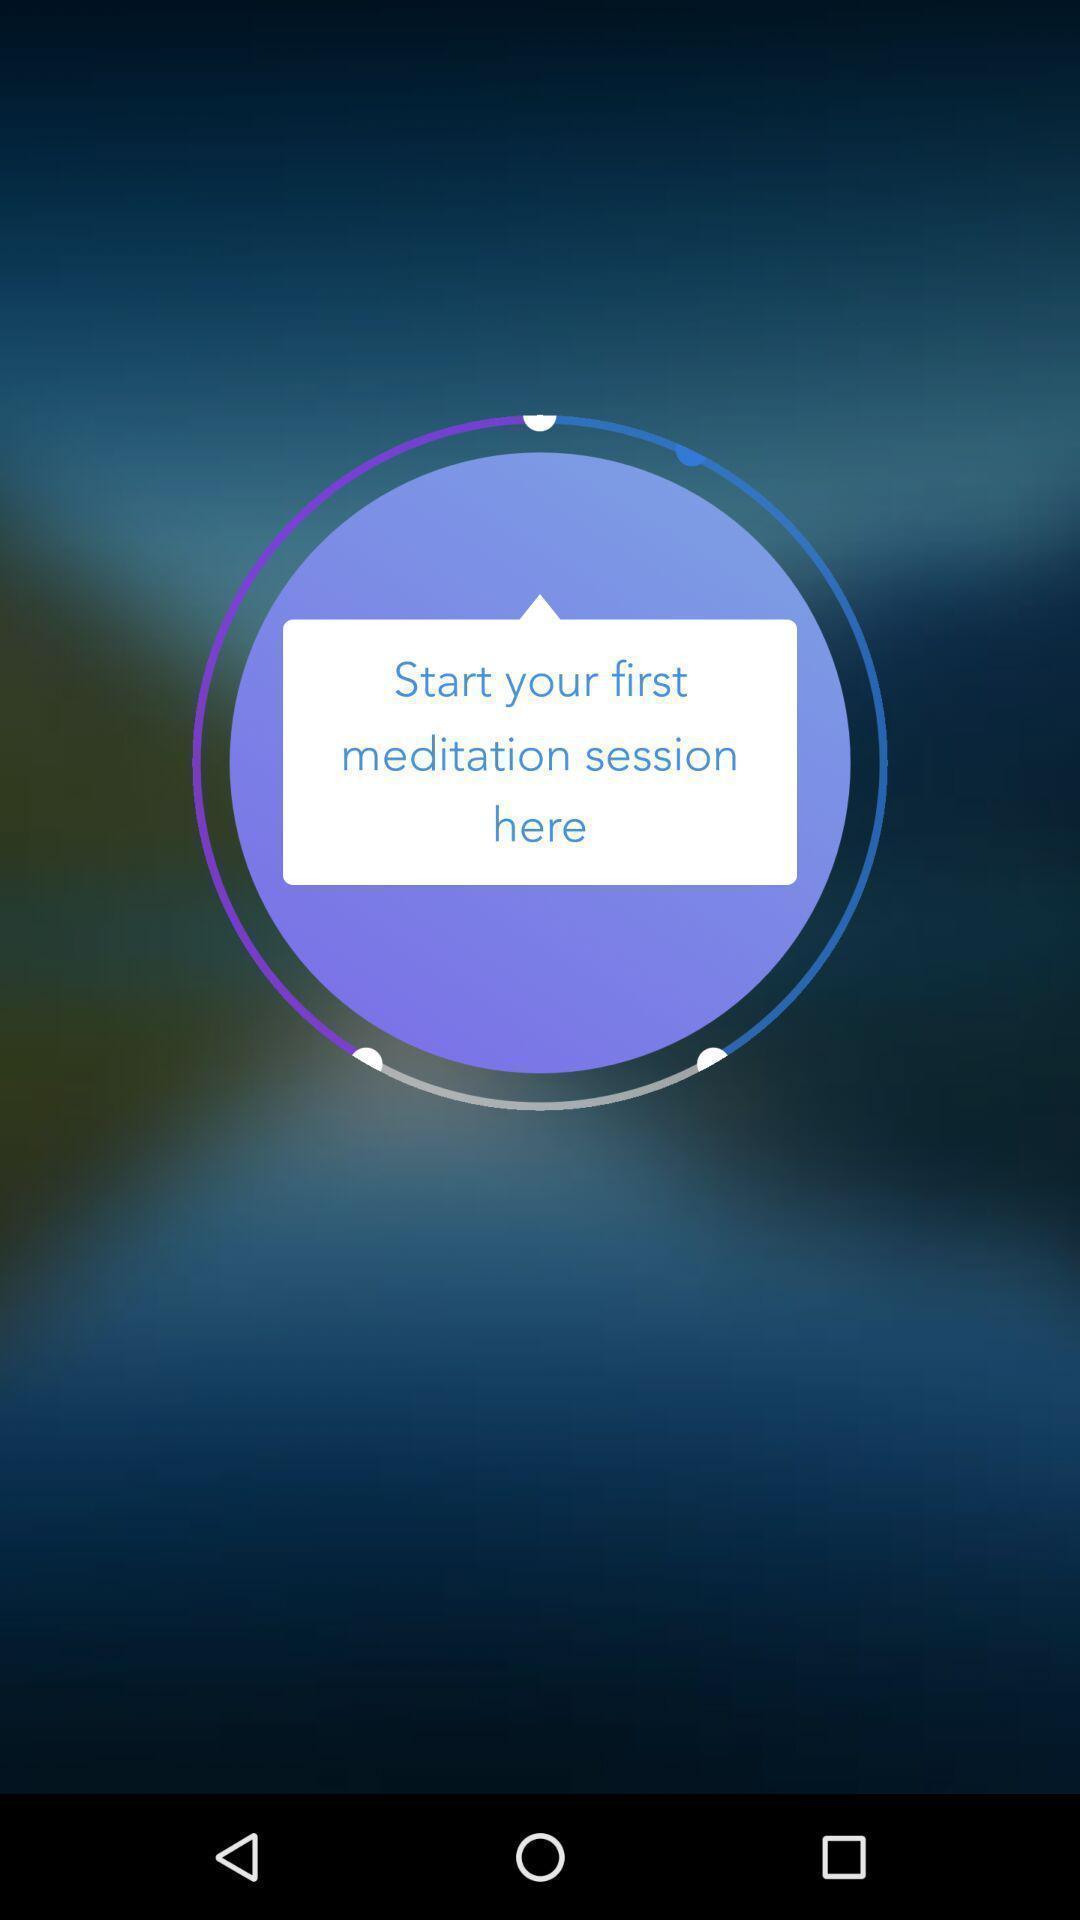Please provide a description for this image. Welcome page of a fitness app. 